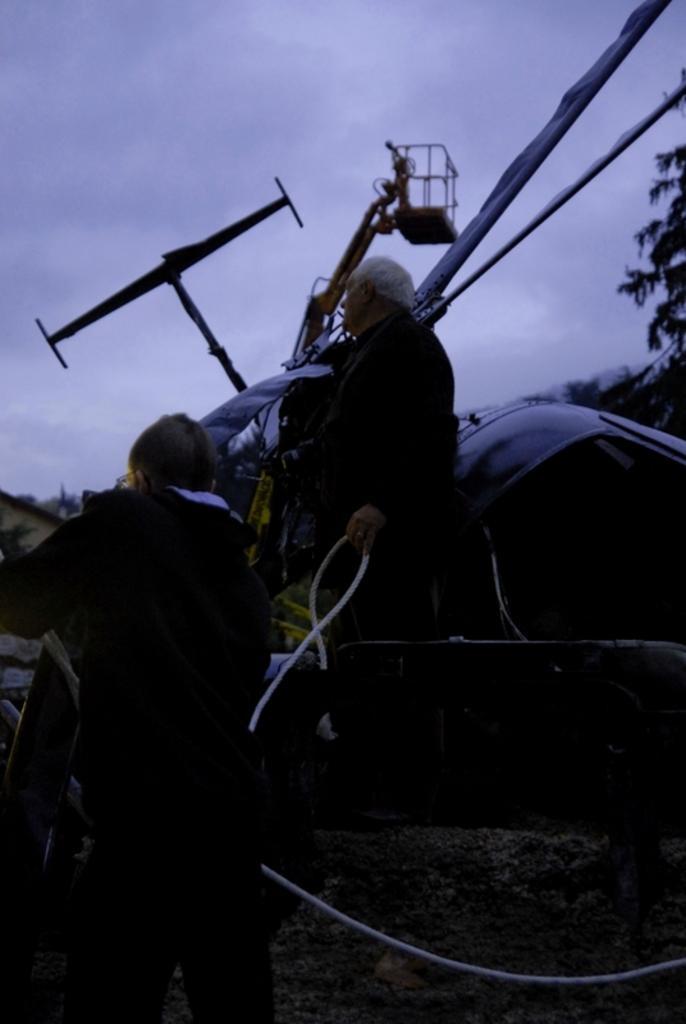Can you describe this image briefly? On the left side a man is standing, he wore black color sweater. At the top it is the sky. 